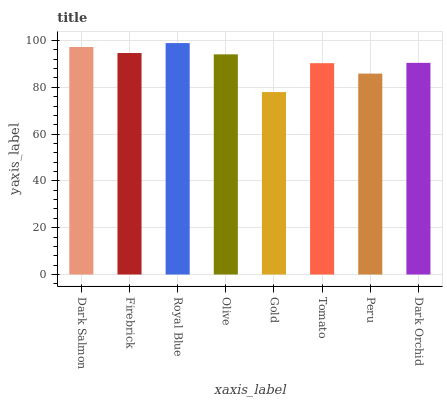Is Gold the minimum?
Answer yes or no. Yes. Is Royal Blue the maximum?
Answer yes or no. Yes. Is Firebrick the minimum?
Answer yes or no. No. Is Firebrick the maximum?
Answer yes or no. No. Is Dark Salmon greater than Firebrick?
Answer yes or no. Yes. Is Firebrick less than Dark Salmon?
Answer yes or no. Yes. Is Firebrick greater than Dark Salmon?
Answer yes or no. No. Is Dark Salmon less than Firebrick?
Answer yes or no. No. Is Olive the high median?
Answer yes or no. Yes. Is Dark Orchid the low median?
Answer yes or no. Yes. Is Gold the high median?
Answer yes or no. No. Is Dark Salmon the low median?
Answer yes or no. No. 